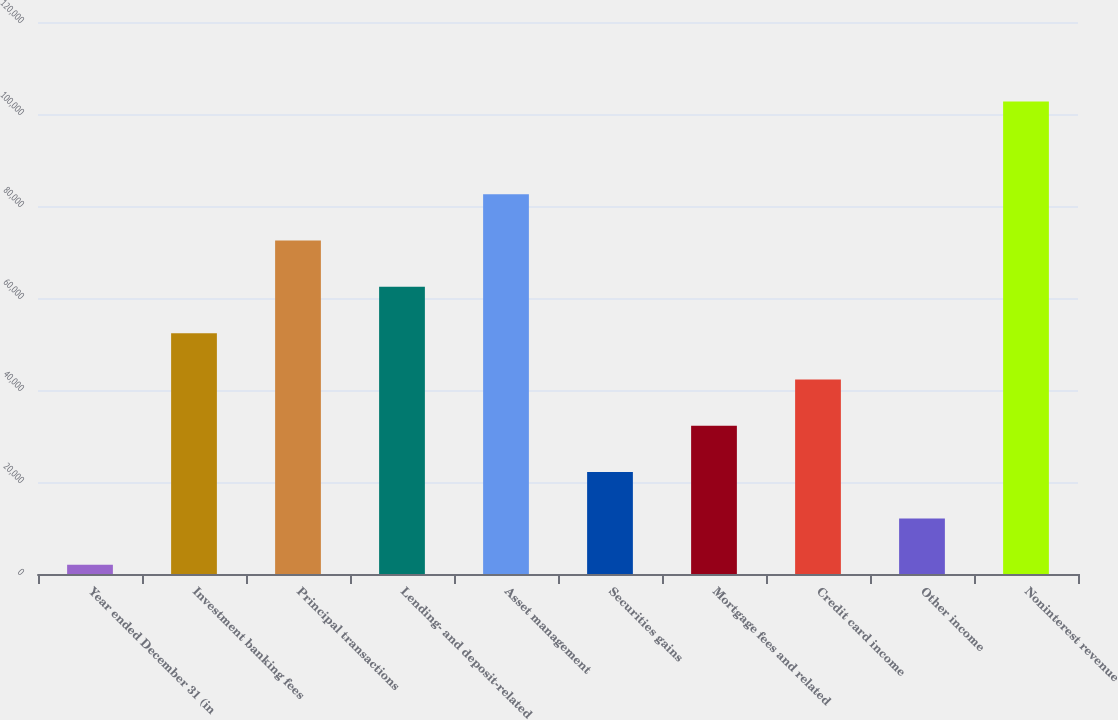Convert chart. <chart><loc_0><loc_0><loc_500><loc_500><bar_chart><fcel>Year ended December 31 (in<fcel>Investment banking fees<fcel>Principal transactions<fcel>Lending- and deposit-related<fcel>Asset management<fcel>Securities gains<fcel>Mortgage fees and related<fcel>Credit card income<fcel>Other income<fcel>Noninterest revenue<nl><fcel>2010<fcel>52352<fcel>72488.8<fcel>62420.4<fcel>82557.2<fcel>22146.8<fcel>32215.2<fcel>42283.6<fcel>12078.4<fcel>102694<nl></chart> 